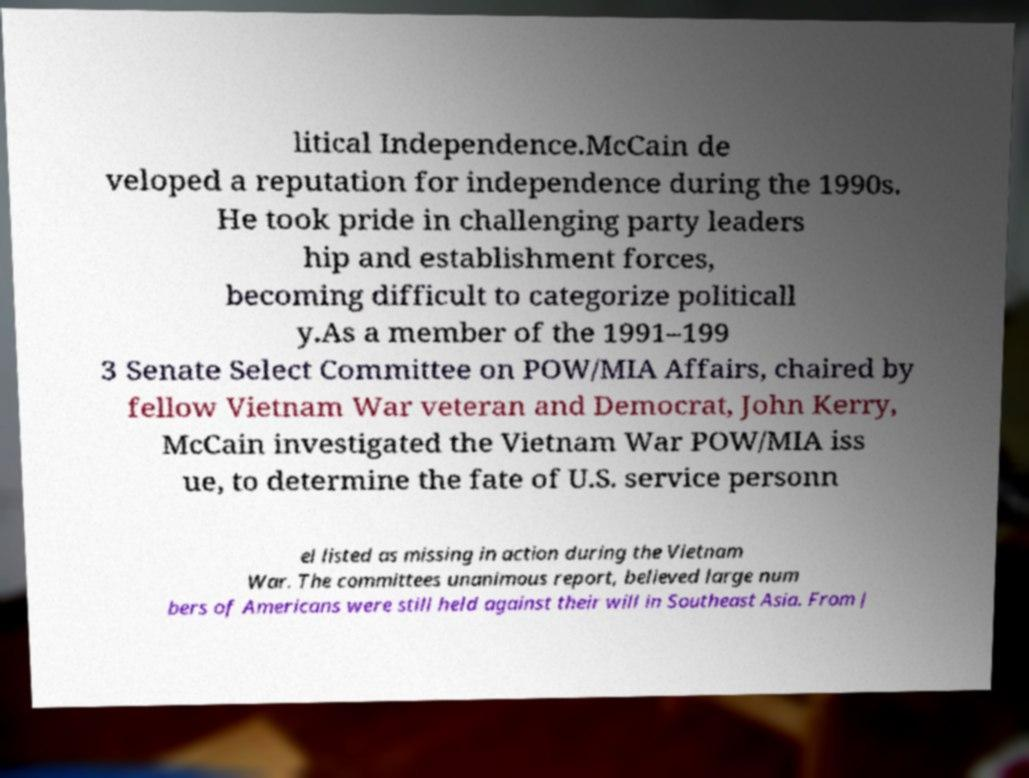I need the written content from this picture converted into text. Can you do that? litical Independence.McCain de veloped a reputation for independence during the 1990s. He took pride in challenging party leaders hip and establishment forces, becoming difficult to categorize politicall y.As a member of the 1991–199 3 Senate Select Committee on POW/MIA Affairs, chaired by fellow Vietnam War veteran and Democrat, John Kerry, McCain investigated the Vietnam War POW/MIA iss ue, to determine the fate of U.S. service personn el listed as missing in action during the Vietnam War. The committees unanimous report, believed large num bers of Americans were still held against their will in Southeast Asia. From J 